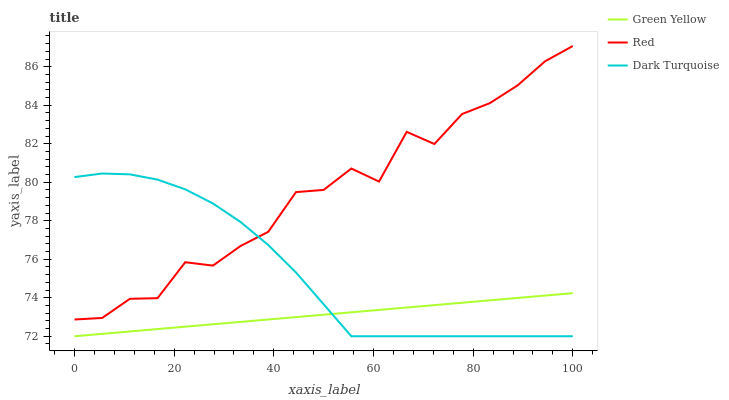Does Green Yellow have the minimum area under the curve?
Answer yes or no. Yes. Does Red have the maximum area under the curve?
Answer yes or no. Yes. Does Red have the minimum area under the curve?
Answer yes or no. No. Does Green Yellow have the maximum area under the curve?
Answer yes or no. No. Is Green Yellow the smoothest?
Answer yes or no. Yes. Is Red the roughest?
Answer yes or no. Yes. Is Red the smoothest?
Answer yes or no. No. Is Green Yellow the roughest?
Answer yes or no. No. Does Dark Turquoise have the lowest value?
Answer yes or no. Yes. Does Red have the lowest value?
Answer yes or no. No. Does Red have the highest value?
Answer yes or no. Yes. Does Green Yellow have the highest value?
Answer yes or no. No. Is Green Yellow less than Red?
Answer yes or no. Yes. Is Red greater than Green Yellow?
Answer yes or no. Yes. Does Red intersect Dark Turquoise?
Answer yes or no. Yes. Is Red less than Dark Turquoise?
Answer yes or no. No. Is Red greater than Dark Turquoise?
Answer yes or no. No. Does Green Yellow intersect Red?
Answer yes or no. No. 